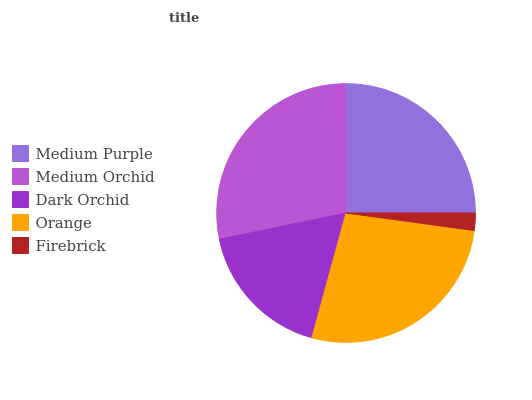Is Firebrick the minimum?
Answer yes or no. Yes. Is Medium Orchid the maximum?
Answer yes or no. Yes. Is Dark Orchid the minimum?
Answer yes or no. No. Is Dark Orchid the maximum?
Answer yes or no. No. Is Medium Orchid greater than Dark Orchid?
Answer yes or no. Yes. Is Dark Orchid less than Medium Orchid?
Answer yes or no. Yes. Is Dark Orchid greater than Medium Orchid?
Answer yes or no. No. Is Medium Orchid less than Dark Orchid?
Answer yes or no. No. Is Medium Purple the high median?
Answer yes or no. Yes. Is Medium Purple the low median?
Answer yes or no. Yes. Is Orange the high median?
Answer yes or no. No. Is Medium Orchid the low median?
Answer yes or no. No. 